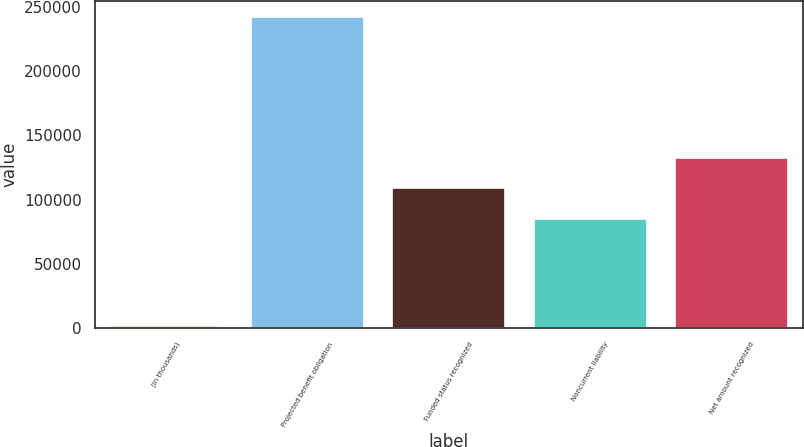<chart> <loc_0><loc_0><loc_500><loc_500><bar_chart><fcel>(In thousands)<fcel>Projected benefit obligation<fcel>Funded status recognized<fcel>Noncurrent liability<fcel>Net amount recognized<nl><fcel>2018<fcel>241902<fcel>108578<fcel>84590<fcel>132567<nl></chart> 